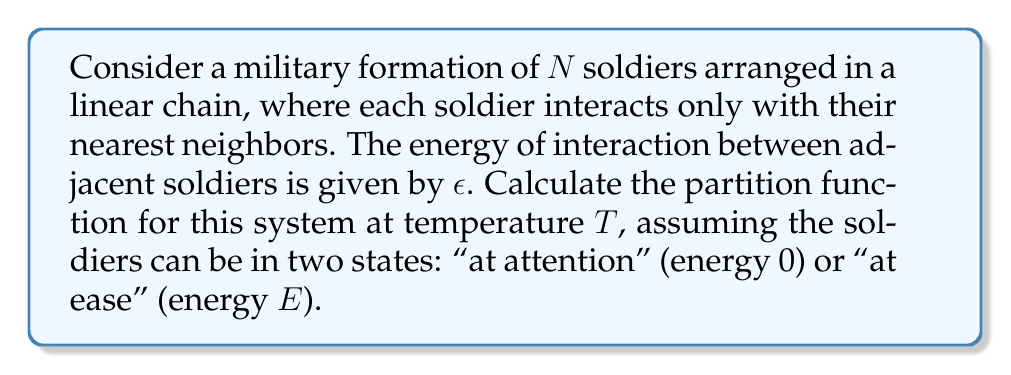Give your solution to this math problem. Let's approach this step-by-step:

1) First, we need to define the partition function. For a system with discrete energy states, it's given by:

   $$Z = \sum_i e^{-\beta E_i}$$

   where $\beta = \frac{1}{k_B T}$, $k_B$ is Boltzmann's constant, and $E_i$ are the possible energy states.

2) In our system, each soldier can be in two states: "at attention" (0) or "at ease" ($E$). The total energy also includes the interaction energy $\epsilon$ between adjacent soldiers.

3) For a system of $N$ soldiers, there are $2^N$ possible configurations. However, we can use the transfer matrix method to simplify our calculation.

4) Let's define a 2x2 transfer matrix $T$:

   $$T = \begin{pmatrix} 
   1 & e^{-\beta E} \\
   e^{-\beta E} & e^{-\beta(2E+\epsilon)}
   \end{pmatrix}$$

   The elements of this matrix represent the Boltzmann factors for the four possible configurations of two adjacent soldiers.

5) The partition function can be expressed in terms of this transfer matrix:

   $$Z = \text{Tr}(T^N)$$

   where Tr denotes the trace of the matrix.

6) To calculate this, we need to find the eigenvalues of $T$. The characteristic equation is:

   $$\lambda^2 - (1 + e^{-\beta(2E+\epsilon)})\lambda + e^{-\beta E}(e^{-\beta E} - e^{-\beta \epsilon}) = 0$$

7) The solutions to this equation are the eigenvalues $\lambda_1$ and $\lambda_2$. The partition function is then:

   $$Z = \lambda_1^N + \lambda_2^N$$

8) For large $N$, this can be approximated as:

   $$Z \approx \lambda_+^N$$

   where $\lambda_+$ is the larger eigenvalue.
Answer: $Z \approx \lambda_+^N$, where $\lambda_+$ is the larger eigenvalue of the transfer matrix $T$. 